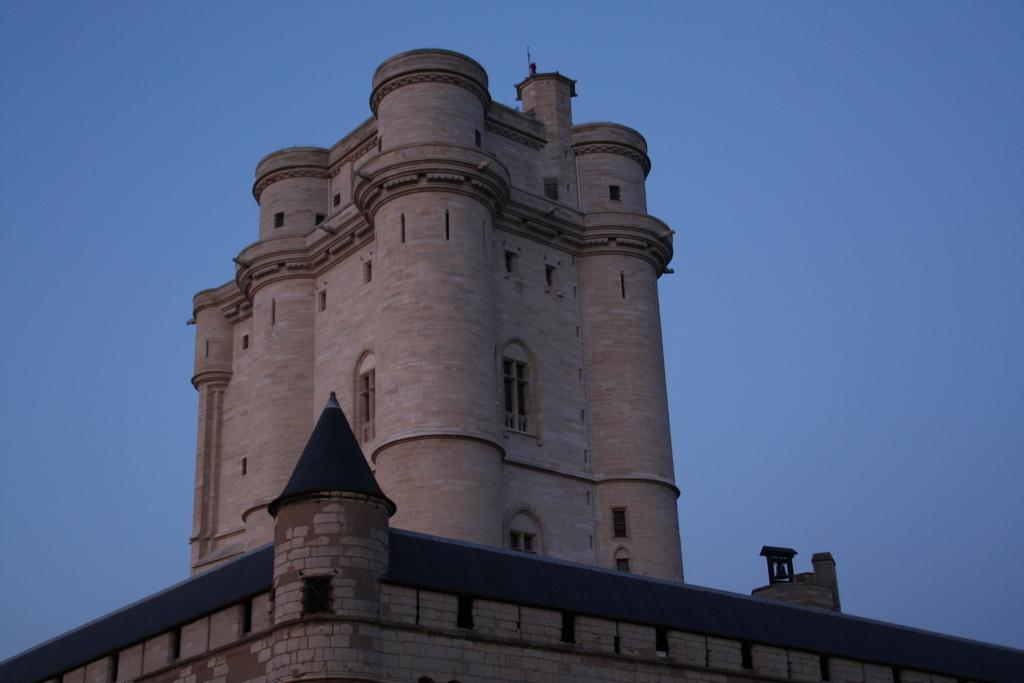What is the main subject in the picture? There is a building in the picture. What can be seen in the background of the picture? The sky is visible in the background of the picture. What type of salt is being used to mark the territory around the building in the image? There is no salt or territory marking present in the image; it only features a building and the sky in the background. 